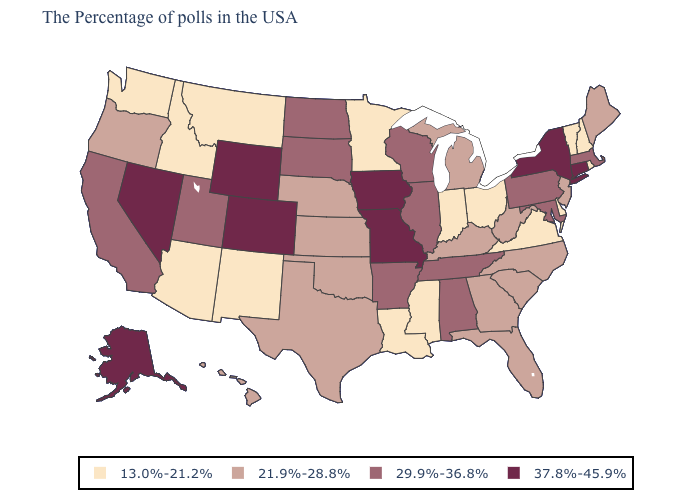Does the first symbol in the legend represent the smallest category?
Give a very brief answer. Yes. Among the states that border Wisconsin , which have the lowest value?
Quick response, please. Minnesota. Name the states that have a value in the range 13.0%-21.2%?
Concise answer only. Rhode Island, New Hampshire, Vermont, Delaware, Virginia, Ohio, Indiana, Mississippi, Louisiana, Minnesota, New Mexico, Montana, Arizona, Idaho, Washington. Name the states that have a value in the range 37.8%-45.9%?
Keep it brief. Connecticut, New York, Missouri, Iowa, Wyoming, Colorado, Nevada, Alaska. What is the lowest value in the USA?
Quick response, please. 13.0%-21.2%. Name the states that have a value in the range 37.8%-45.9%?
Write a very short answer. Connecticut, New York, Missouri, Iowa, Wyoming, Colorado, Nevada, Alaska. What is the value of Nevada?
Concise answer only. 37.8%-45.9%. Name the states that have a value in the range 13.0%-21.2%?
Quick response, please. Rhode Island, New Hampshire, Vermont, Delaware, Virginia, Ohio, Indiana, Mississippi, Louisiana, Minnesota, New Mexico, Montana, Arizona, Idaho, Washington. Which states have the lowest value in the USA?
Keep it brief. Rhode Island, New Hampshire, Vermont, Delaware, Virginia, Ohio, Indiana, Mississippi, Louisiana, Minnesota, New Mexico, Montana, Arizona, Idaho, Washington. Does Iowa have the highest value in the MidWest?
Short answer required. Yes. Among the states that border New Jersey , does New York have the highest value?
Give a very brief answer. Yes. Name the states that have a value in the range 13.0%-21.2%?
Concise answer only. Rhode Island, New Hampshire, Vermont, Delaware, Virginia, Ohio, Indiana, Mississippi, Louisiana, Minnesota, New Mexico, Montana, Arizona, Idaho, Washington. Does Alaska have the highest value in the West?
Give a very brief answer. Yes. Does Iowa have the highest value in the USA?
Quick response, please. Yes. Among the states that border Delaware , does Maryland have the lowest value?
Keep it brief. No. 